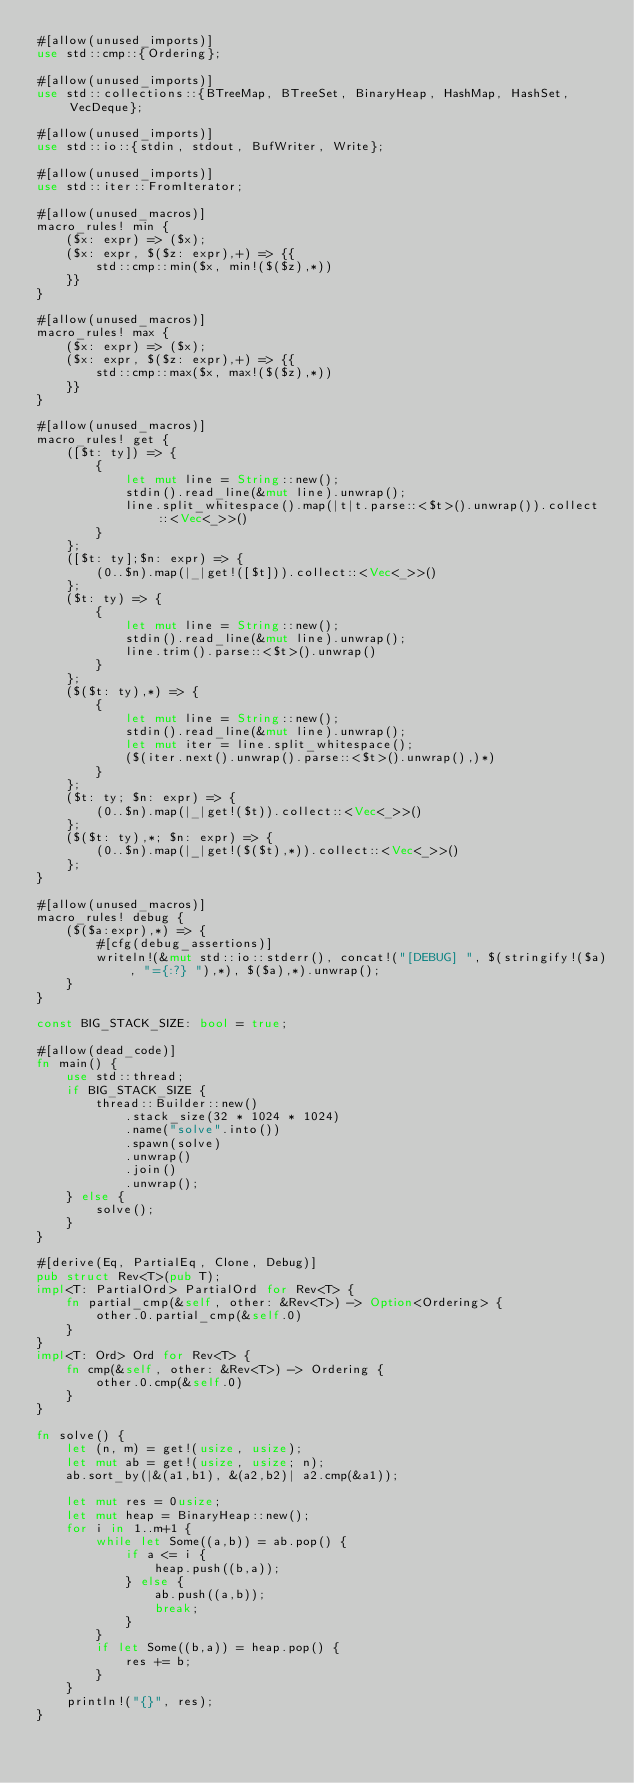<code> <loc_0><loc_0><loc_500><loc_500><_Rust_>#[allow(unused_imports)]
use std::cmp::{Ordering};

#[allow(unused_imports)]
use std::collections::{BTreeMap, BTreeSet, BinaryHeap, HashMap, HashSet, VecDeque};

#[allow(unused_imports)]
use std::io::{stdin, stdout, BufWriter, Write};

#[allow(unused_imports)]
use std::iter::FromIterator;

#[allow(unused_macros)]
macro_rules! min {
    ($x: expr) => ($x);
    ($x: expr, $($z: expr),+) => {{
        std::cmp::min($x, min!($($z),*))
    }}
}

#[allow(unused_macros)]
macro_rules! max {
    ($x: expr) => ($x);
    ($x: expr, $($z: expr),+) => {{
        std::cmp::max($x, max!($($z),*))
    }}
}

#[allow(unused_macros)]
macro_rules! get { 
    ([$t: ty]) => { 
        { 
            let mut line = String::new(); 
            stdin().read_line(&mut line).unwrap(); 
            line.split_whitespace().map(|t|t.parse::<$t>().unwrap()).collect::<Vec<_>>()
        }
    };
    ([$t: ty];$n: expr) => {
        (0..$n).map(|_|get!([$t])).collect::<Vec<_>>()
    };
    ($t: ty) => {
        {
            let mut line = String::new();
            stdin().read_line(&mut line).unwrap();
            line.trim().parse::<$t>().unwrap()
        }
    };
    ($($t: ty),*) => {
        { 
            let mut line = String::new();
            stdin().read_line(&mut line).unwrap();
            let mut iter = line.split_whitespace();
            ($(iter.next().unwrap().parse::<$t>().unwrap(),)*)
        }
    };
    ($t: ty; $n: expr) => {
        (0..$n).map(|_|get!($t)).collect::<Vec<_>>()
    };
    ($($t: ty),*; $n: expr) => {
        (0..$n).map(|_|get!($($t),*)).collect::<Vec<_>>()
    };
}

#[allow(unused_macros)]
macro_rules! debug {
    ($($a:expr),*) => {
        #[cfg(debug_assertions)]
        writeln!(&mut std::io::stderr(), concat!("[DEBUG] ", $(stringify!($a), "={:?} "),*), $($a),*).unwrap();
    }
}

const BIG_STACK_SIZE: bool = true;

#[allow(dead_code)]
fn main() {
    use std::thread;
    if BIG_STACK_SIZE {
        thread::Builder::new()
            .stack_size(32 * 1024 * 1024)
            .name("solve".into())
            .spawn(solve)
            .unwrap()
            .join()
            .unwrap();
    } else {
        solve();
    }
}

#[derive(Eq, PartialEq, Clone, Debug)]
pub struct Rev<T>(pub T);
impl<T: PartialOrd> PartialOrd for Rev<T> {
    fn partial_cmp(&self, other: &Rev<T>) -> Option<Ordering> {
        other.0.partial_cmp(&self.0)
    }
}
impl<T: Ord> Ord for Rev<T> {
    fn cmp(&self, other: &Rev<T>) -> Ordering {
        other.0.cmp(&self.0)
    }
}

fn solve() {
    let (n, m) = get!(usize, usize);
    let mut ab = get!(usize, usize; n);
    ab.sort_by(|&(a1,b1), &(a2,b2)| a2.cmp(&a1));

    let mut res = 0usize;
    let mut heap = BinaryHeap::new();
    for i in 1..m+1 {
        while let Some((a,b)) = ab.pop() {
            if a <= i {
                heap.push((b,a));
            } else {
                ab.push((a,b));
                break;
            }
        }
        if let Some((b,a)) = heap.pop() {
            res += b;
        }
    }
    println!("{}", res);
}
</code> 